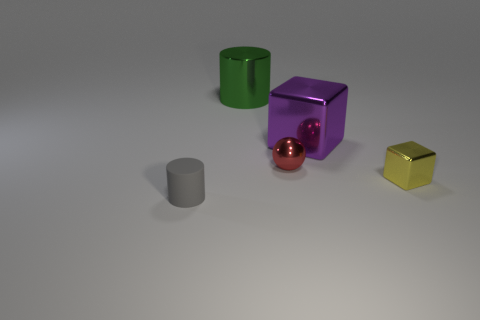How many objects are either tiny metal objects in front of the green metallic cylinder or big yellow metallic blocks?
Make the answer very short. 2. There is a small metallic object that is behind the small thing that is right of the metal sphere; what number of large green things are right of it?
Your answer should be compact. 0. Is there anything else that has the same size as the gray matte cylinder?
Provide a short and direct response. Yes. What shape is the tiny gray matte object that is left of the large metal thing that is in front of the thing that is behind the large metal block?
Your answer should be very brief. Cylinder. What number of other objects are there of the same color as the large metallic cube?
Your answer should be compact. 0. The object that is on the right side of the big thing that is to the right of the green object is what shape?
Keep it short and to the point. Cube. How many small red shiny spheres are on the right side of the tiny cube?
Your answer should be very brief. 0. Are there any big objects made of the same material as the green cylinder?
Offer a very short reply. Yes. What material is the purple cube that is the same size as the green thing?
Make the answer very short. Metal. What is the size of the object that is both in front of the tiny ball and behind the tiny gray matte cylinder?
Keep it short and to the point. Small. 